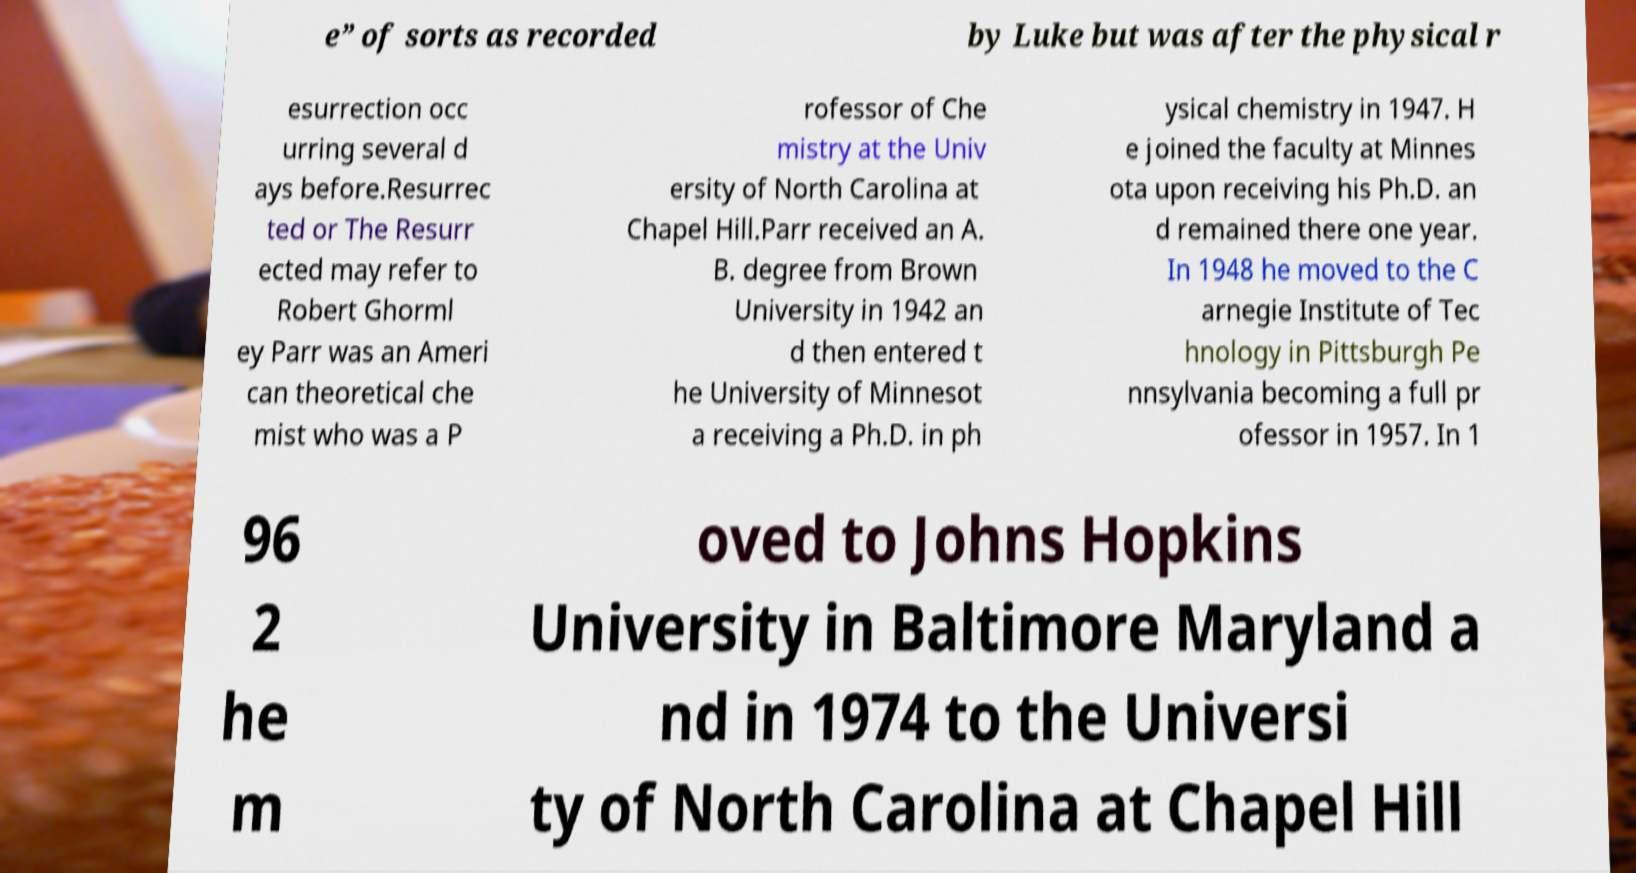Can you read and provide the text displayed in the image?This photo seems to have some interesting text. Can you extract and type it out for me? e” of sorts as recorded by Luke but was after the physical r esurrection occ urring several d ays before.Resurrec ted or The Resurr ected may refer to Robert Ghorml ey Parr was an Ameri can theoretical che mist who was a P rofessor of Che mistry at the Univ ersity of North Carolina at Chapel Hill.Parr received an A. B. degree from Brown University in 1942 an d then entered t he University of Minnesot a receiving a Ph.D. in ph ysical chemistry in 1947. H e joined the faculty at Minnes ota upon receiving his Ph.D. an d remained there one year. In 1948 he moved to the C arnegie Institute of Tec hnology in Pittsburgh Pe nnsylvania becoming a full pr ofessor in 1957. In 1 96 2 he m oved to Johns Hopkins University in Baltimore Maryland a nd in 1974 to the Universi ty of North Carolina at Chapel Hill 